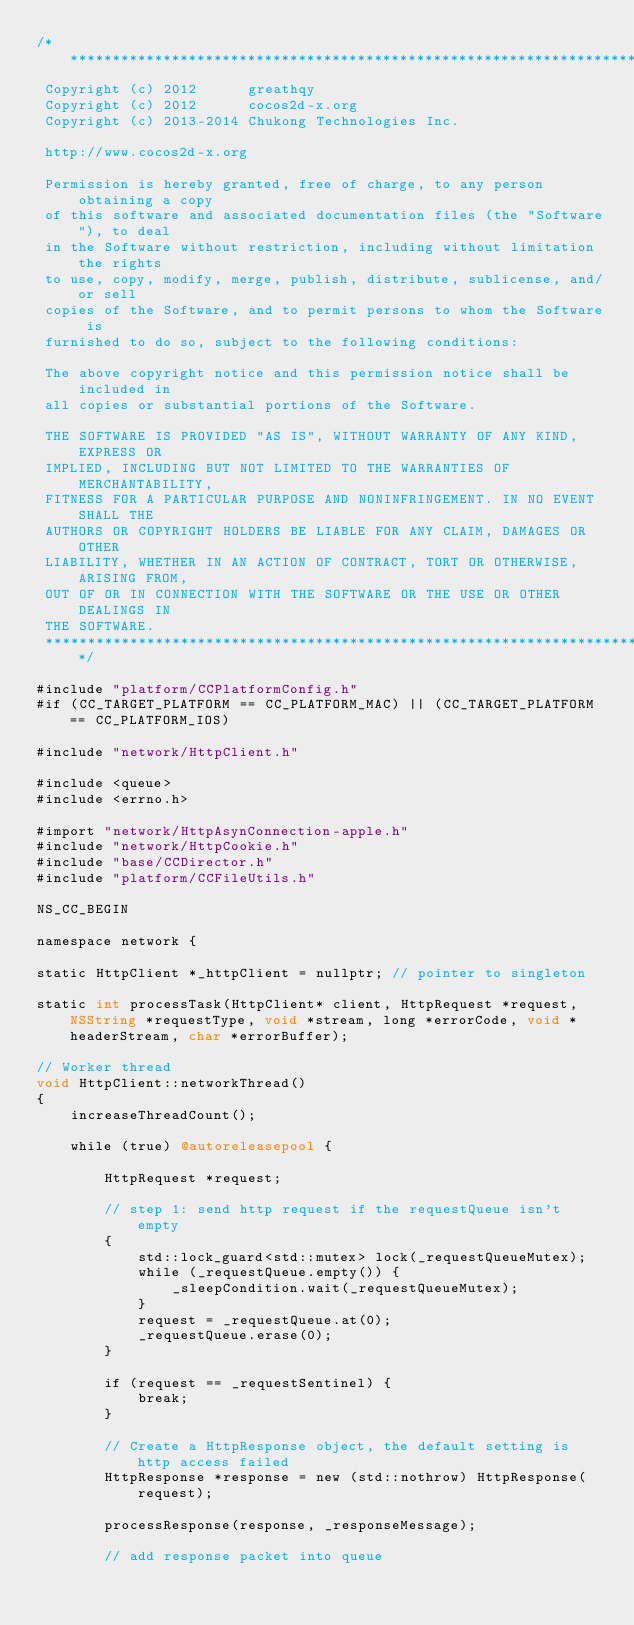<code> <loc_0><loc_0><loc_500><loc_500><_ObjectiveC_>/****************************************************************************
 Copyright (c) 2012      greathqy
 Copyright (c) 2012      cocos2d-x.org
 Copyright (c) 2013-2014 Chukong Technologies Inc.
 
 http://www.cocos2d-x.org
 
 Permission is hereby granted, free of charge, to any person obtaining a copy
 of this software and associated documentation files (the "Software"), to deal
 in the Software without restriction, including without limitation the rights
 to use, copy, modify, merge, publish, distribute, sublicense, and/or sell
 copies of the Software, and to permit persons to whom the Software is
 furnished to do so, subject to the following conditions:
 
 The above copyright notice and this permission notice shall be included in
 all copies or substantial portions of the Software.
 
 THE SOFTWARE IS PROVIDED "AS IS", WITHOUT WARRANTY OF ANY KIND, EXPRESS OR
 IMPLIED, INCLUDING BUT NOT LIMITED TO THE WARRANTIES OF MERCHANTABILITY,
 FITNESS FOR A PARTICULAR PURPOSE AND NONINFRINGEMENT. IN NO EVENT SHALL THE
 AUTHORS OR COPYRIGHT HOLDERS BE LIABLE FOR ANY CLAIM, DAMAGES OR OTHER
 LIABILITY, WHETHER IN AN ACTION OF CONTRACT, TORT OR OTHERWISE, ARISING FROM,
 OUT OF OR IN CONNECTION WITH THE SOFTWARE OR THE USE OR OTHER DEALINGS IN
 THE SOFTWARE.
 ****************************************************************************/

#include "platform/CCPlatformConfig.h"
#if (CC_TARGET_PLATFORM == CC_PLATFORM_MAC) || (CC_TARGET_PLATFORM == CC_PLATFORM_IOS)

#include "network/HttpClient.h"

#include <queue>
#include <errno.h>

#import "network/HttpAsynConnection-apple.h"
#include "network/HttpCookie.h"
#include "base/CCDirector.h"
#include "platform/CCFileUtils.h"

NS_CC_BEGIN

namespace network {
    
static HttpClient *_httpClient = nullptr; // pointer to singleton

static int processTask(HttpClient* client, HttpRequest *request, NSString *requestType, void *stream, long *errorCode, void *headerStream, char *errorBuffer);

// Worker thread
void HttpClient::networkThread()
{
    increaseThreadCount();
    
    while (true) @autoreleasepool {
        
        HttpRequest *request;

        // step 1: send http request if the requestQueue isn't empty
        {
            std::lock_guard<std::mutex> lock(_requestQueueMutex);
            while (_requestQueue.empty()) {
                _sleepCondition.wait(_requestQueueMutex);
            }
            request = _requestQueue.at(0);
            _requestQueue.erase(0);
        }

        if (request == _requestSentinel) {
            break;
        }
        
        // Create a HttpResponse object, the default setting is http access failed
        HttpResponse *response = new (std::nothrow) HttpResponse(request);
        
        processResponse(response, _responseMessage);
        
        // add response packet into queue</code> 